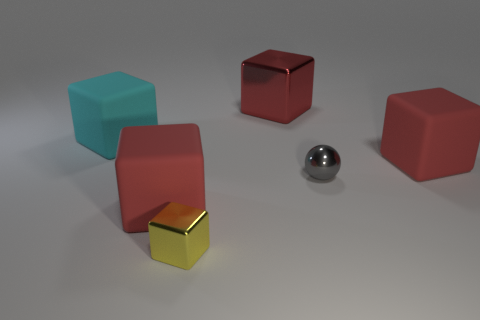If you had to guess, what time of day does the lighting in the image resemble? Given the image is likely a controlled studio setup, the lighting doesn't directly correspond to a natural time of day. However, if we were to associate it with a time of day, the soft and diffused shadows could resemble morning or late afternoon light in terms of quality and angle. 